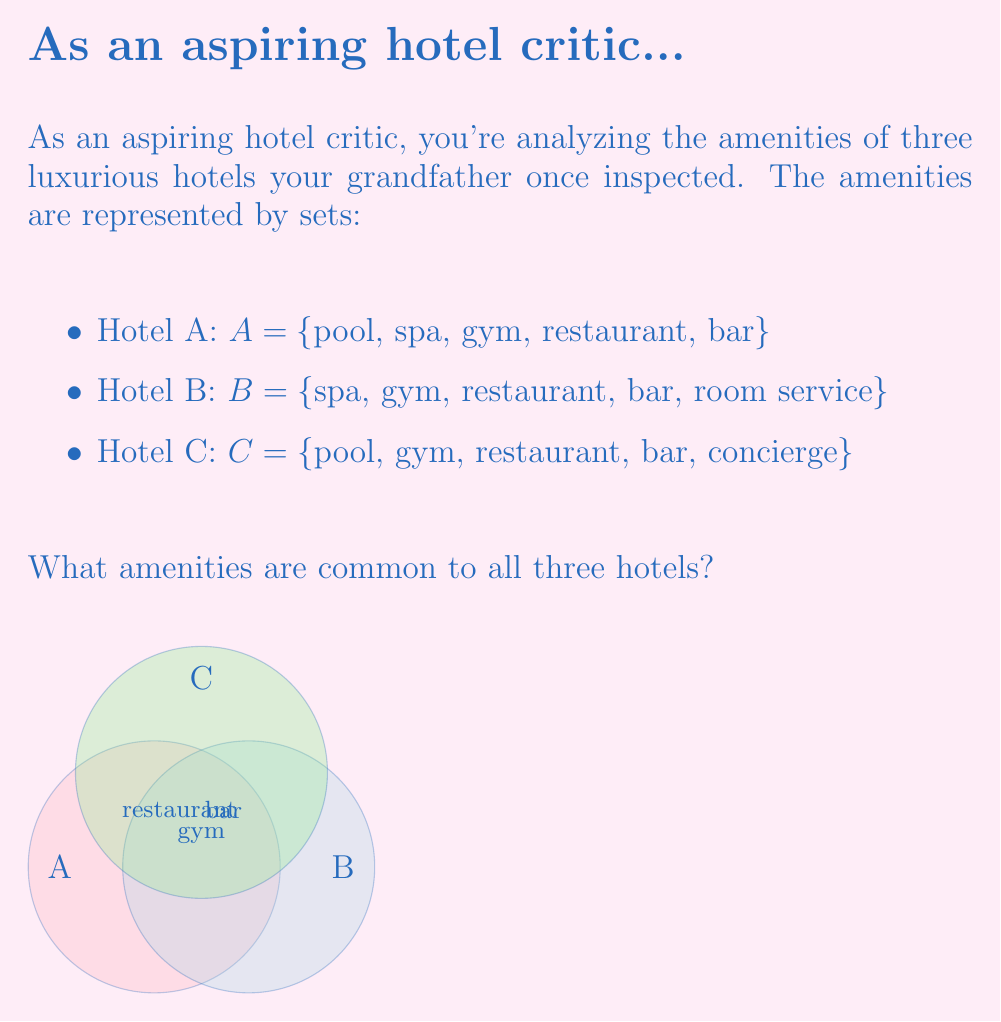Can you answer this question? To find the amenities common to all three hotels, we need to determine the intersection of sets A, B, and C. This is denoted as $A \cap B \cap C$.

Step 1: Identify elements present in all three sets.
- Pool: In A and C, but not in B
- Spa: In A and B, but not in C
- Gym: In A, B, and C
- Restaurant: In A, B, and C
- Bar: In A, B, and C
- Room service: Only in B
- Concierge: Only in C

Step 2: List the elements that appear in all three sets.
$A \cap B \cap C = \{$gym, restaurant, bar$\}$

The Venn diagram in the question visually represents this intersection, showing the common amenities in the central area where all three circles overlap.
Answer: $\{$gym, restaurant, bar$\}$ 